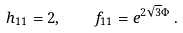Convert formula to latex. <formula><loc_0><loc_0><loc_500><loc_500>h _ { 1 1 } = 2 , \quad f _ { 1 1 } = e ^ { 2 \sqrt { 3 } \Phi } \, .</formula> 